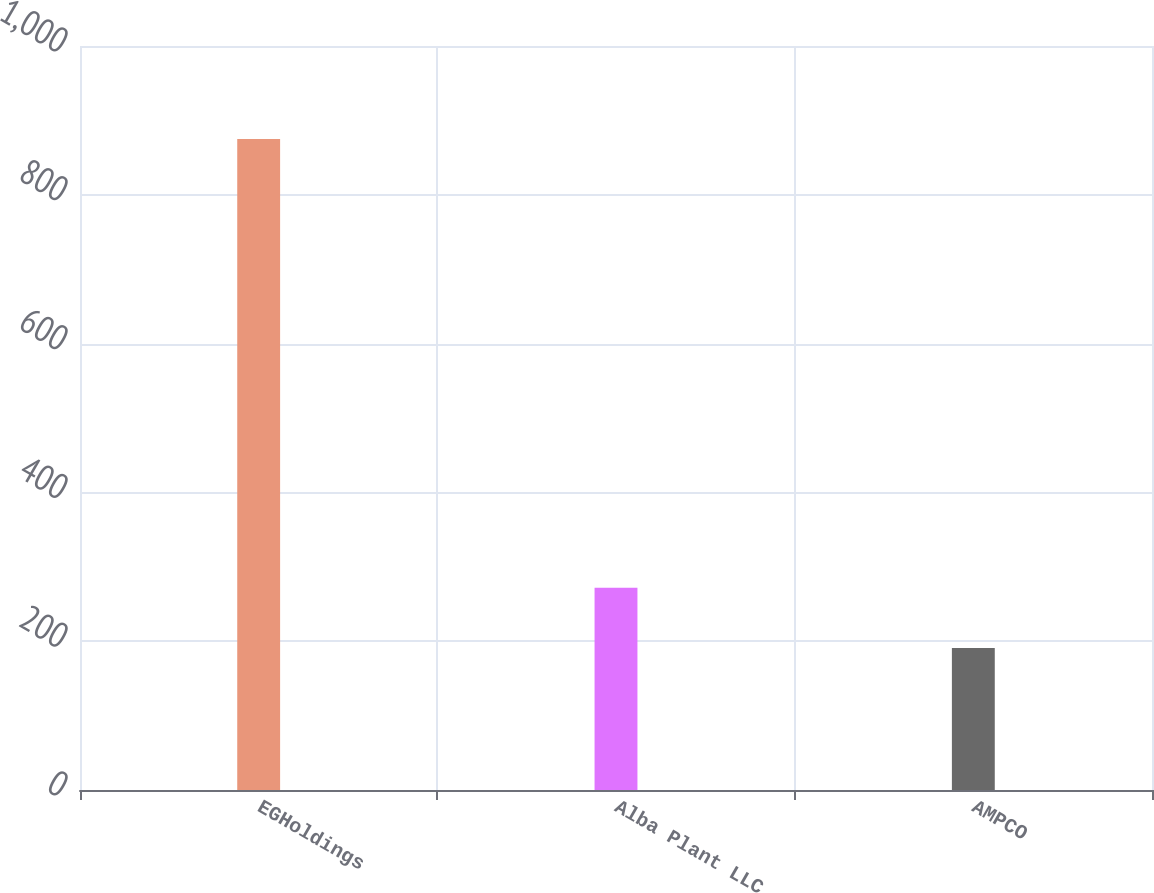Convert chart. <chart><loc_0><loc_0><loc_500><loc_500><bar_chart><fcel>EGHoldings<fcel>Alba Plant LLC<fcel>AMPCO<nl><fcel>875<fcel>272<fcel>191<nl></chart> 